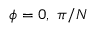Convert formula to latex. <formula><loc_0><loc_0><loc_500><loc_500>\phi = 0 , \pi / N</formula> 